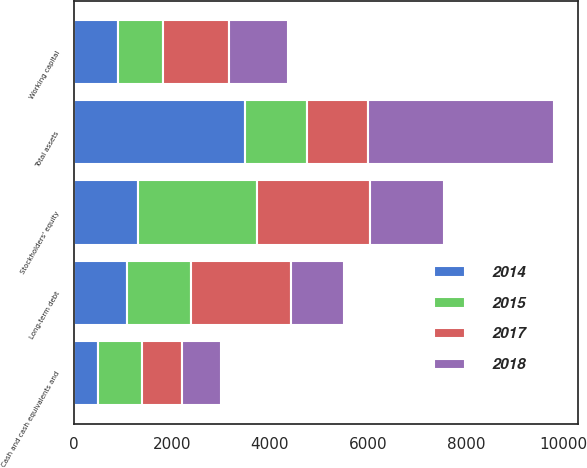Convert chart. <chart><loc_0><loc_0><loc_500><loc_500><stacked_bar_chart><ecel><fcel>Cash and cash equivalents and<fcel>Working capital<fcel>Total assets<fcel>Long-term debt<fcel>Stockholders' equity<nl><fcel>2015<fcel>913<fcel>916<fcel>1250.5<fcel>1291<fcel>2433<nl><fcel>2017<fcel>818<fcel>1358<fcel>1250.5<fcel>2038<fcel>2310<nl><fcel>2018<fcel>783<fcel>1210<fcel>3796<fcel>1093<fcel>1513<nl><fcel>2014<fcel>483<fcel>893<fcel>3501<fcel>1092<fcel>1302<nl></chart> 